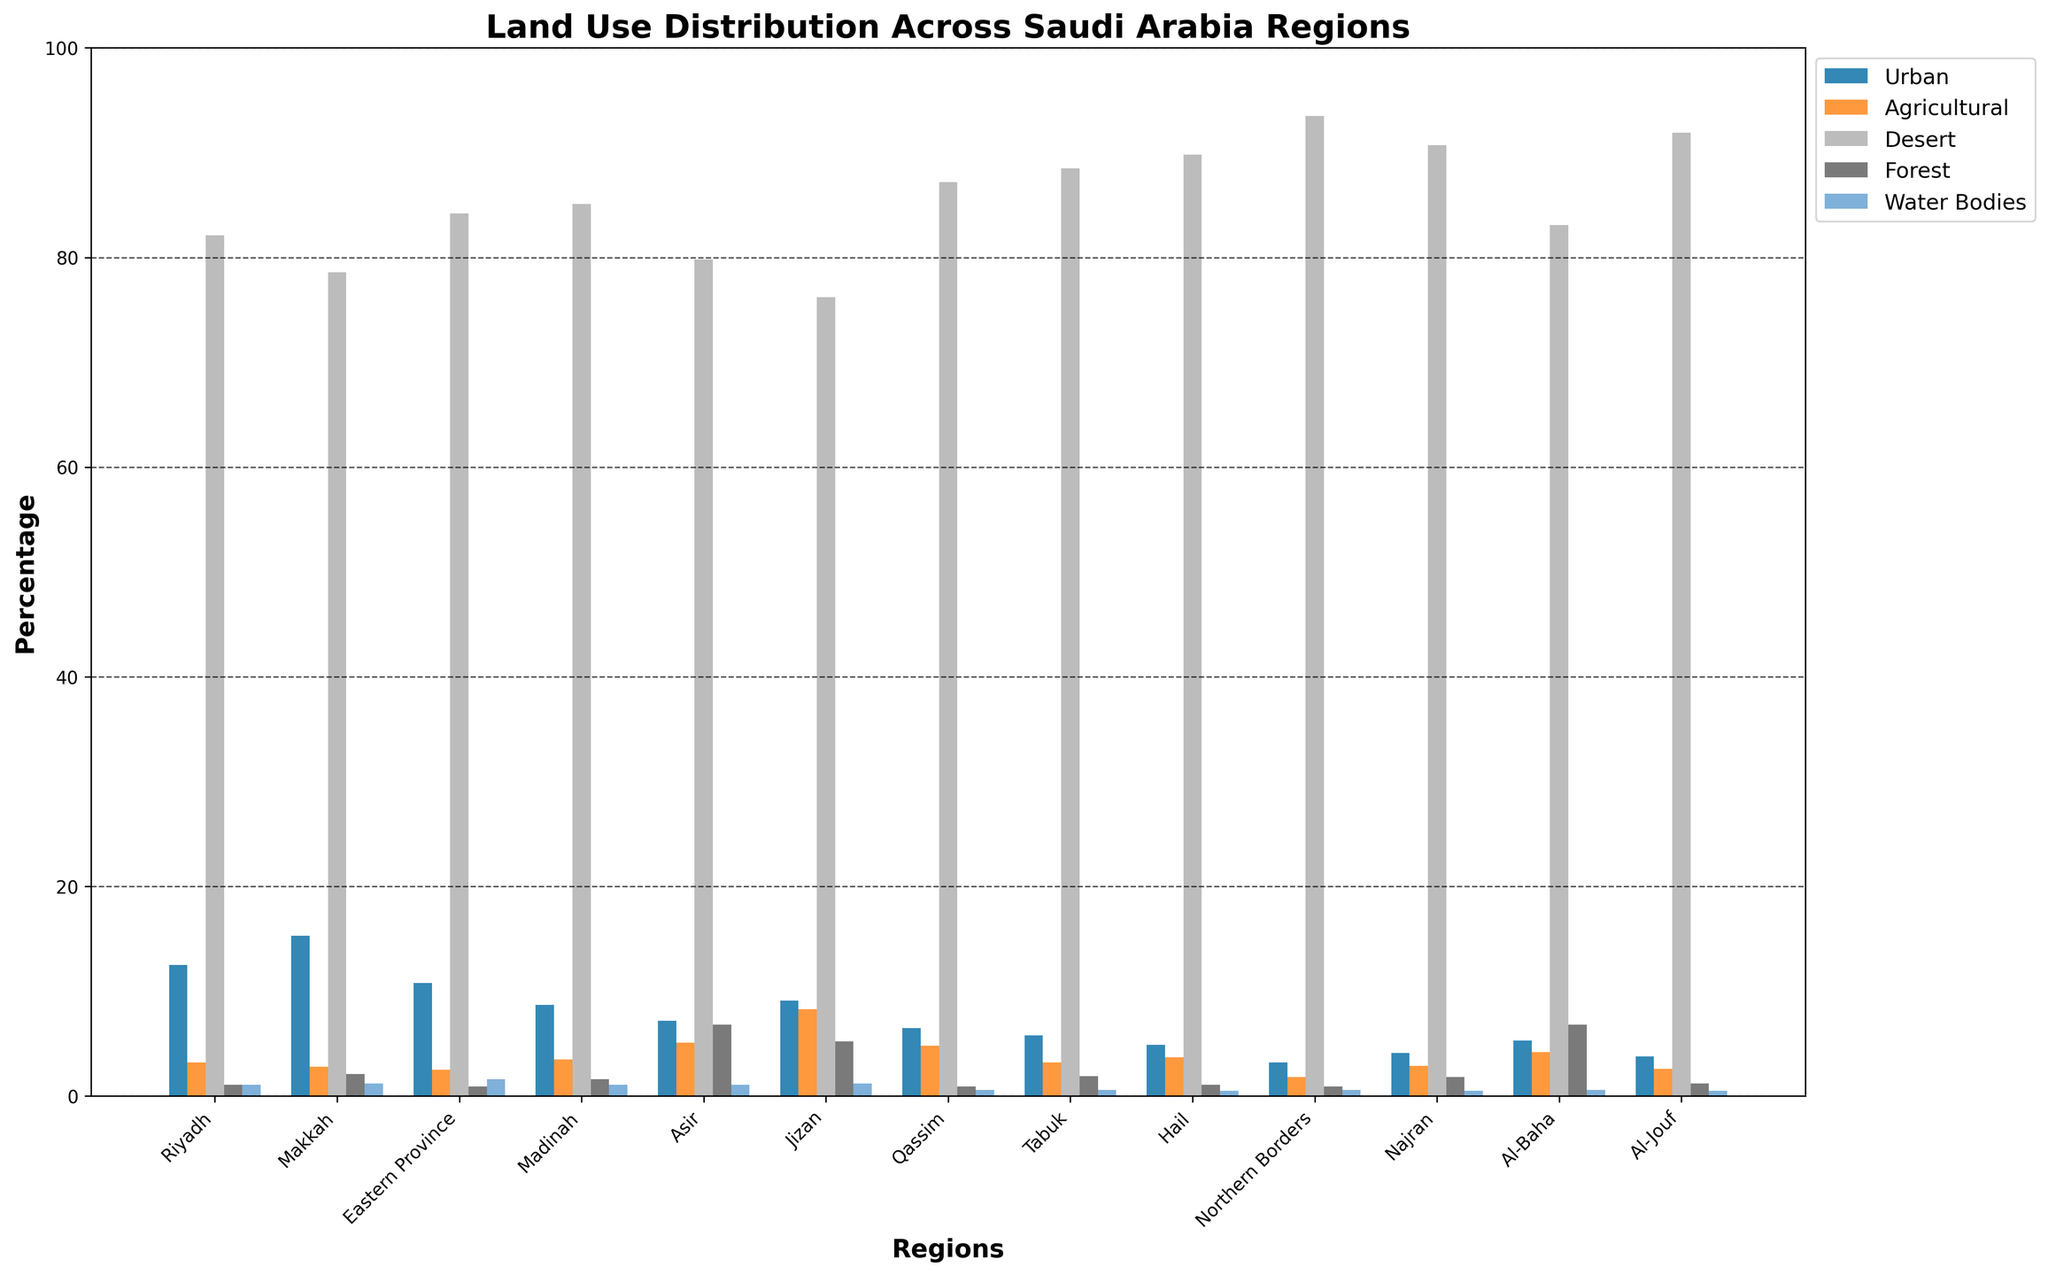Which region has the highest percentage of urban land use? By looking at the height of the bars labeled "Urban", the tallest bar corresponds to the region "Makkah" at 15.3%.
Answer: Makkah Which region has the lowest percentage of forest land use? By comparing the heights of the bars labeled "Forest", the region with the smallest bar is "Eastern Province" at 0.9%.
Answer: Eastern Province What is the difference in the percentage of desert land use between Riyadh and Qassim? The desert land use for Riyadh is 82.1%, and for Qassim is 87.2%. The difference is 87.2% - 82.1% = 5.1%.
Answer: 5.1% Which two regions have the closest percentages of agricultural land use? By looking at the bars labeled "Agricultural", "Riyadh" and "Tabuk" both have 3.2%.
Answer: Riyadh and Tabuk What's the sum of the percentages of forest land use across all regions? The percentages for forest land use are: 1.1, 2.1, 0.9, 1.6, 6.8, 5.2, 0.9, 1.9, 1.1, 0.9, 1.8, 6.8, 1.2. Summing these percentages: 1.1 + 2.1 + 0.9 + 1.6 + 6.8 + 5.2 + 0.9 + 1.9 + 1.1 + 0.9 + 1.8 + 6.8 + 1.2 = 34.3%.
Answer: 34.3% Which region has a higher percentage of urban land use, Al-Jouf or Najran? By examining the "Urban" bars, Al-Jouf has 3.8% and Najran has 4.1%. Since 4.1% is greater, Najran has a higher percentage.
Answer: Najran What's the average percentage of water bodies across all regions? The percentages for water bodies are: 1.1, 1.2, 1.6, 1.1, 1.1, 1.2, 0.6, 0.6, 0.5, 0.6, 0.5, 0.6, 0.5. Summing these percentages: 1.1 + 1.2 + 1.6 + 1.1 + 1.1 + 1.2 + 0.6 + 0.6 + 0.5 + 0.6 + 0.5 + 0.6 + 0.5 = 11.2%. There are 13 regions, so the average is 11.2% / 13 ≈ 0.86%.
Answer: 0.86% Which region has the least total percentage of non-desert land use? By summing the non-desert land use categories (Urban, Agricultural, Forest, Water Bodies) for each region and identifying the smallest sum: Najran has the least (4.1 + 2.9 + 1.8 + 0.5) = 9.3%.
Answer: Najran In which region does the total percentage of Urban and Water Bodies land use exceed 15%? For each region, sum the percentages of Urban and Water Bodies and check if the total is greater than 15%. Only Makkah (15.3 + 1.2) = 16.5%, and Riyadh (12.5 + 1.1) = 13.6% come close, but only Makkah exceeds 15%.
Answer: Makkah 